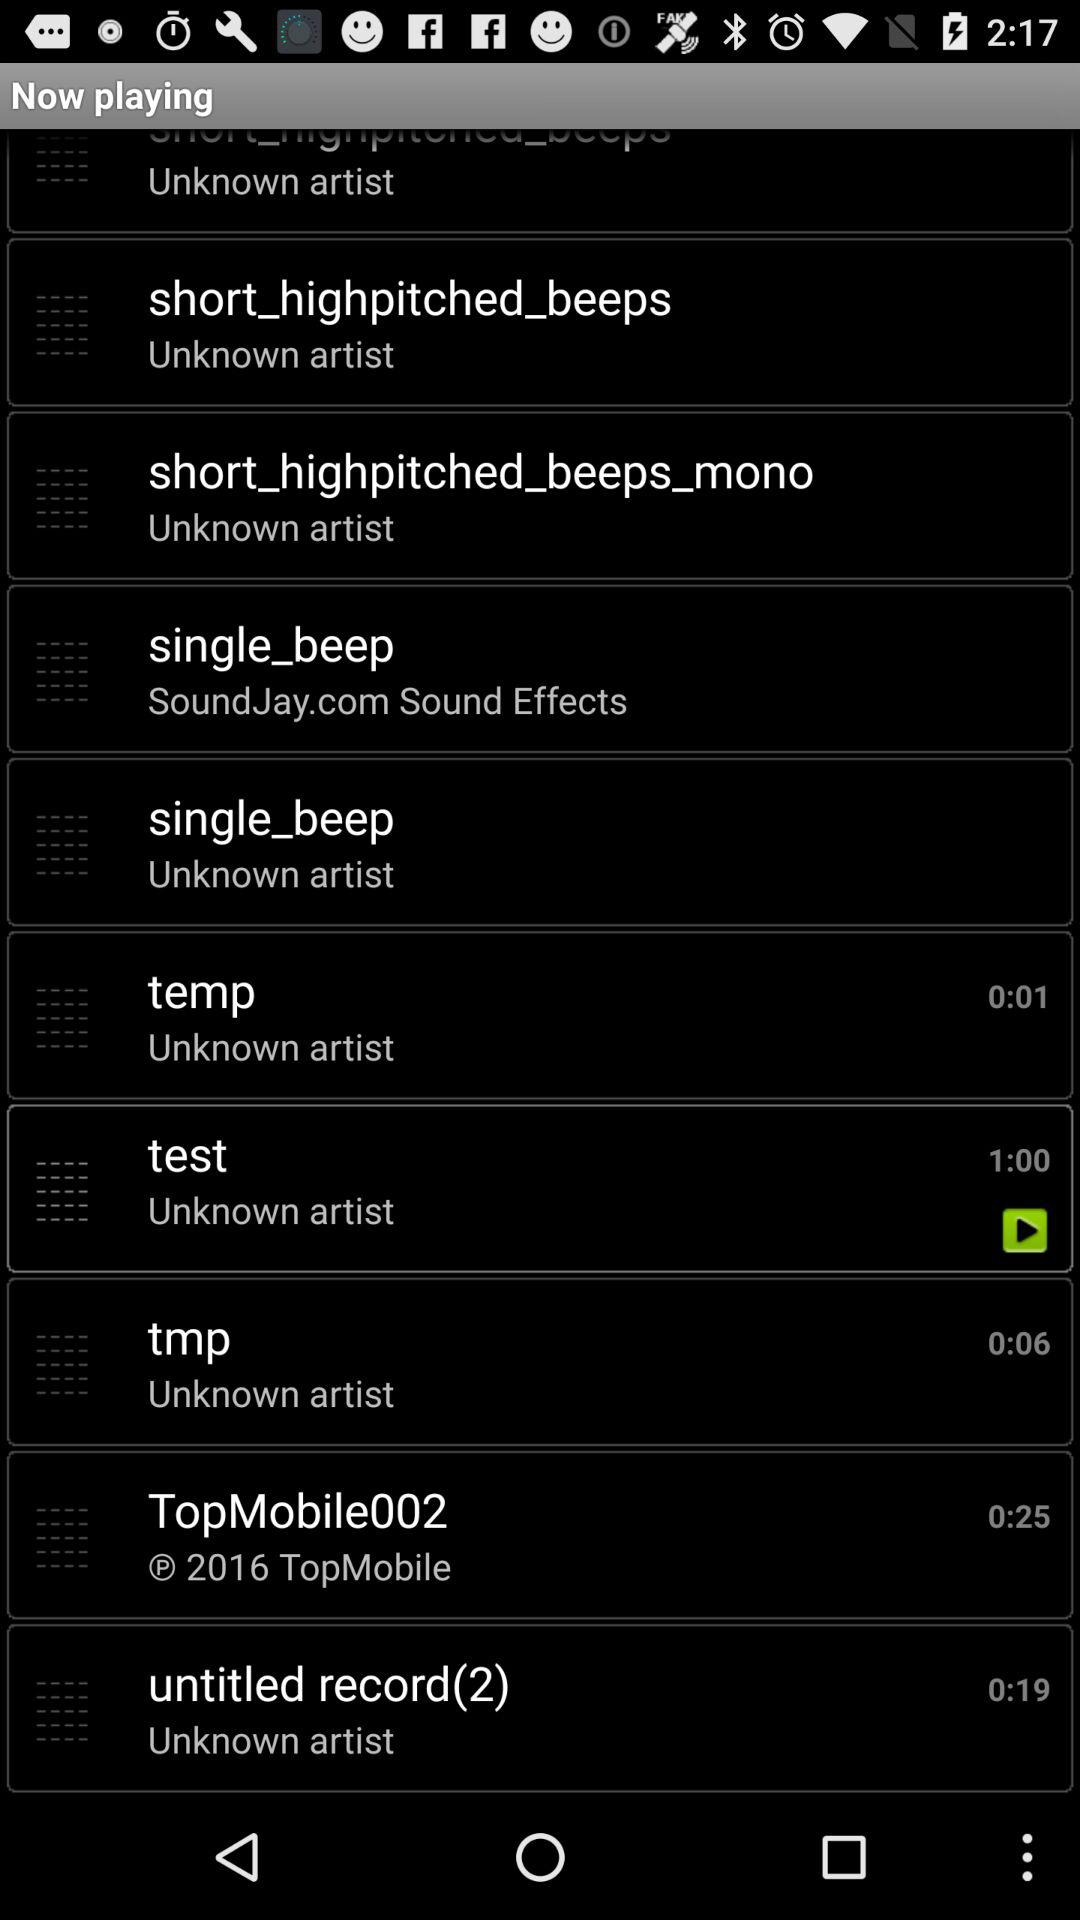What is the number of the untitled record?
When the provided information is insufficient, respond with <no answer>. <no answer> 